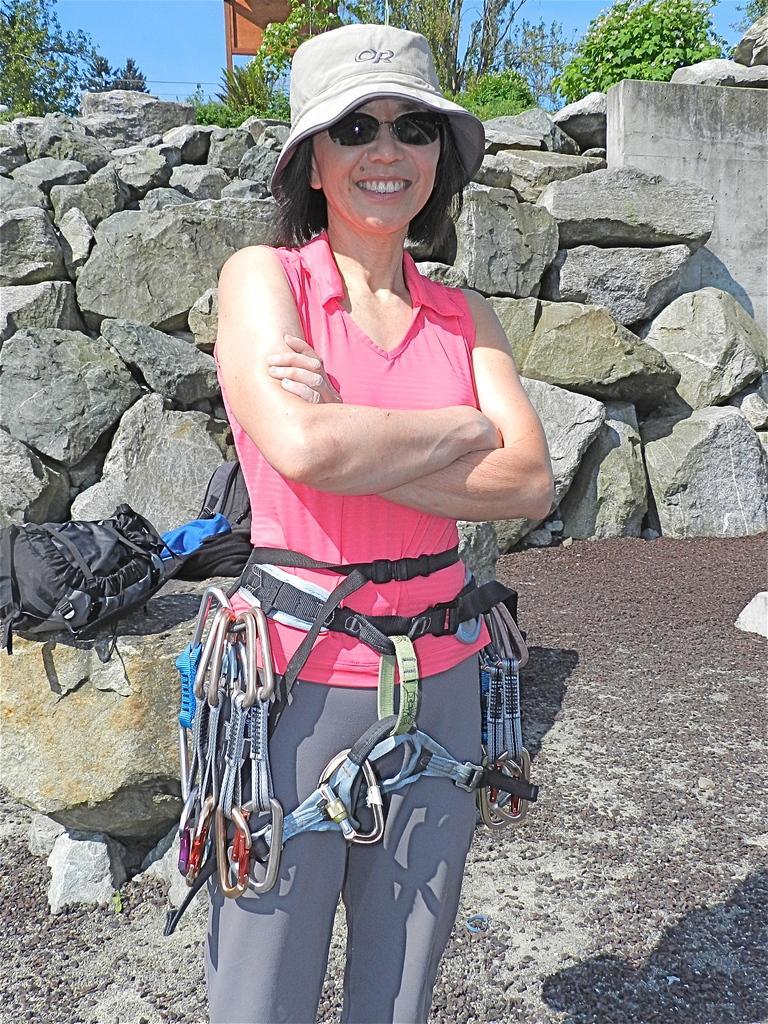Please provide a concise description of this image. In the center of the image we can see a lady standing she is wearing a cap. In the background there are bags, rocks, trees and sky. 